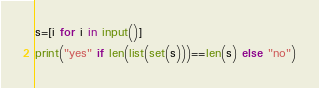Convert code to text. <code><loc_0><loc_0><loc_500><loc_500><_Python_>s=[i for i in input()]
print("yes" if len(list(set(s)))==len(s) else "no")</code> 